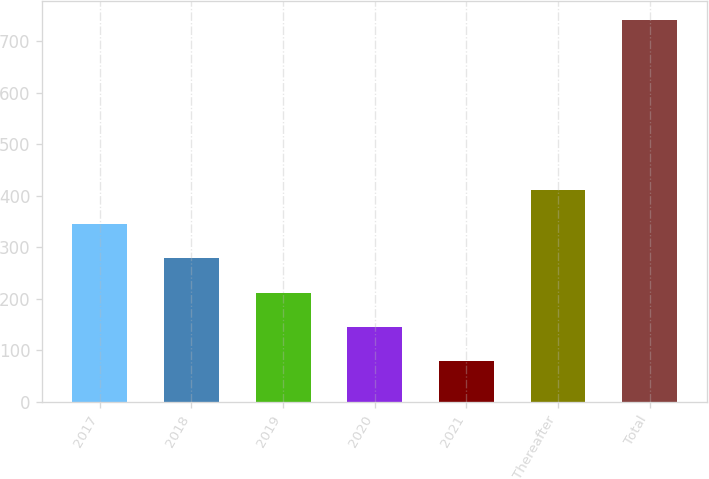Convert chart to OTSL. <chart><loc_0><loc_0><loc_500><loc_500><bar_chart><fcel>2017<fcel>2018<fcel>2019<fcel>2020<fcel>2021<fcel>Thereafter<fcel>Total<nl><fcel>344.8<fcel>278.6<fcel>212.4<fcel>146.2<fcel>80<fcel>411<fcel>742<nl></chart> 